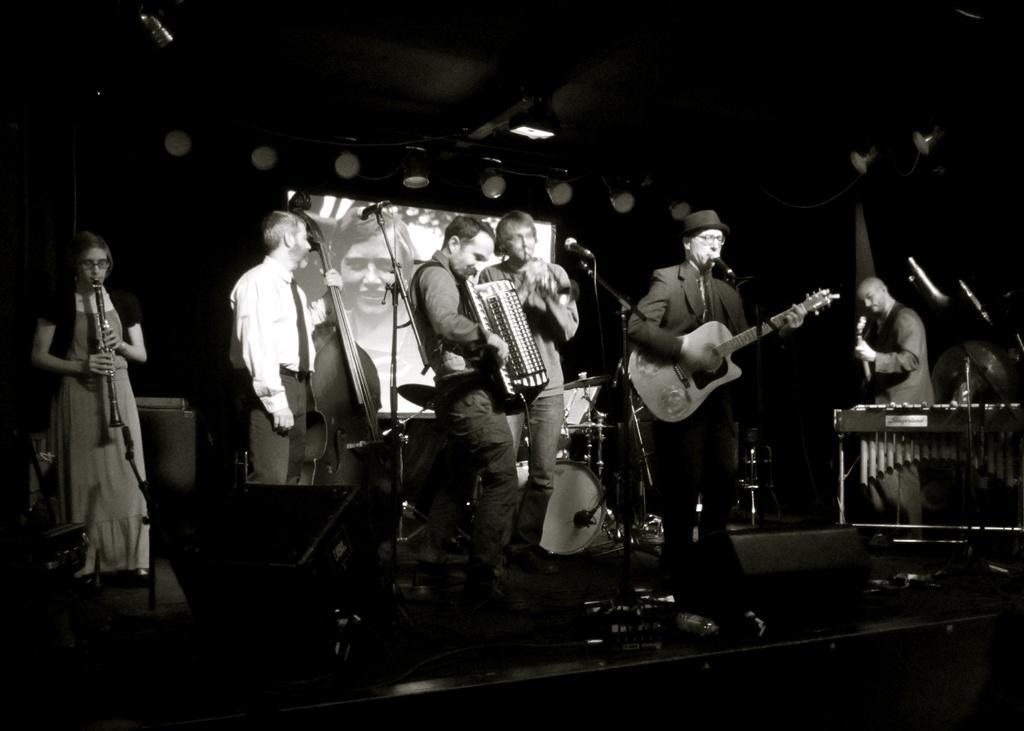How would you summarize this image in a sentence or two? This is a black and white picture, on stage there are group of people who are performing the music. Background of this people there a screen on the screen there is a women. On top of this people there is roof on roof the light is hanging. 